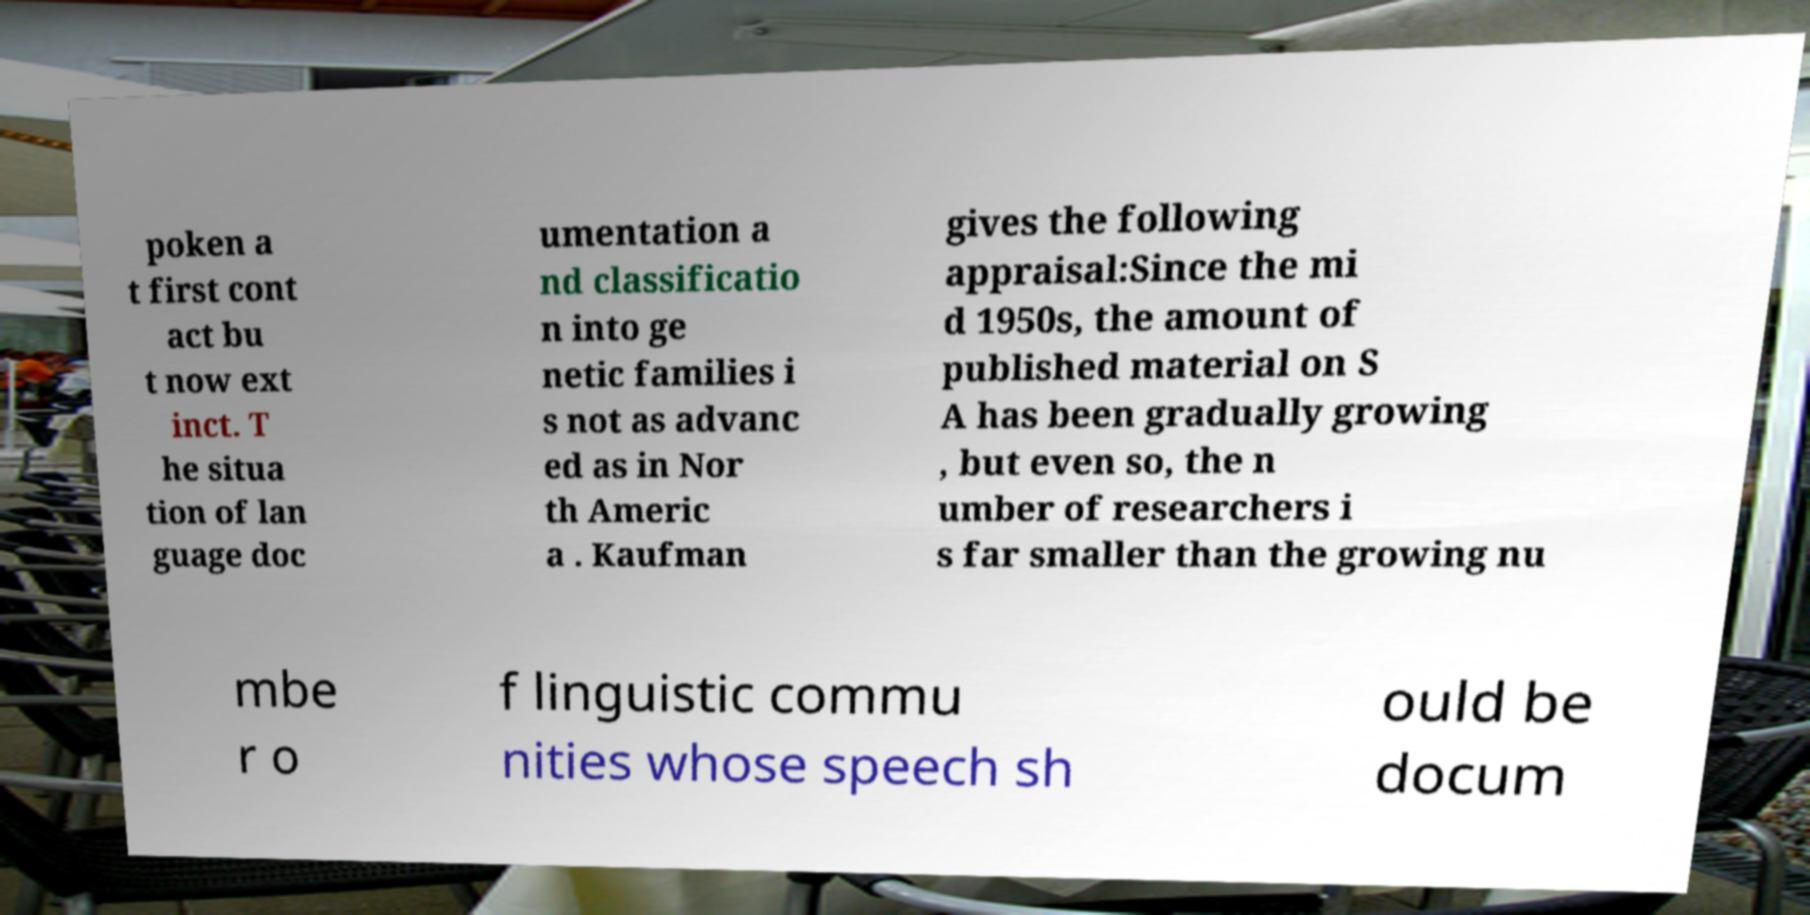Could you extract and type out the text from this image? poken a t first cont act bu t now ext inct. T he situa tion of lan guage doc umentation a nd classificatio n into ge netic families i s not as advanc ed as in Nor th Americ a . Kaufman gives the following appraisal:Since the mi d 1950s, the amount of published material on S A has been gradually growing , but even so, the n umber of researchers i s far smaller than the growing nu mbe r o f linguistic commu nities whose speech sh ould be docum 